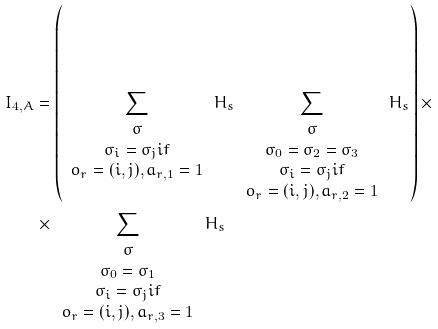Convert formula to latex. <formula><loc_0><loc_0><loc_500><loc_500>I _ { 4 , A } & = \left ( \sum _ { \begin{array} { c } \sigma \\ \sigma _ { i } = \sigma _ { j } i f \\ o _ { r } = ( i , j ) , a _ { r , 1 } = 1 \end{array} } H _ { s } \sum _ { \begin{array} { c } \sigma \\ \sigma _ { 0 } = \sigma _ { 2 } = \sigma _ { 3 } \\ \sigma _ { i } = \sigma _ { j } i f \\ o _ { r } = ( i , j ) , a _ { r , 2 } = 1 \end{array} } H _ { s } \right ) \times \\ & \times \sum _ { \begin{array} { c } \sigma \\ \sigma _ { 0 } = \sigma _ { 1 } \\ \sigma _ { i } = \sigma _ { j } i f \\ o _ { r } = ( i , j ) , a _ { r , 3 } = 1 \end{array} } H _ { s }</formula> 